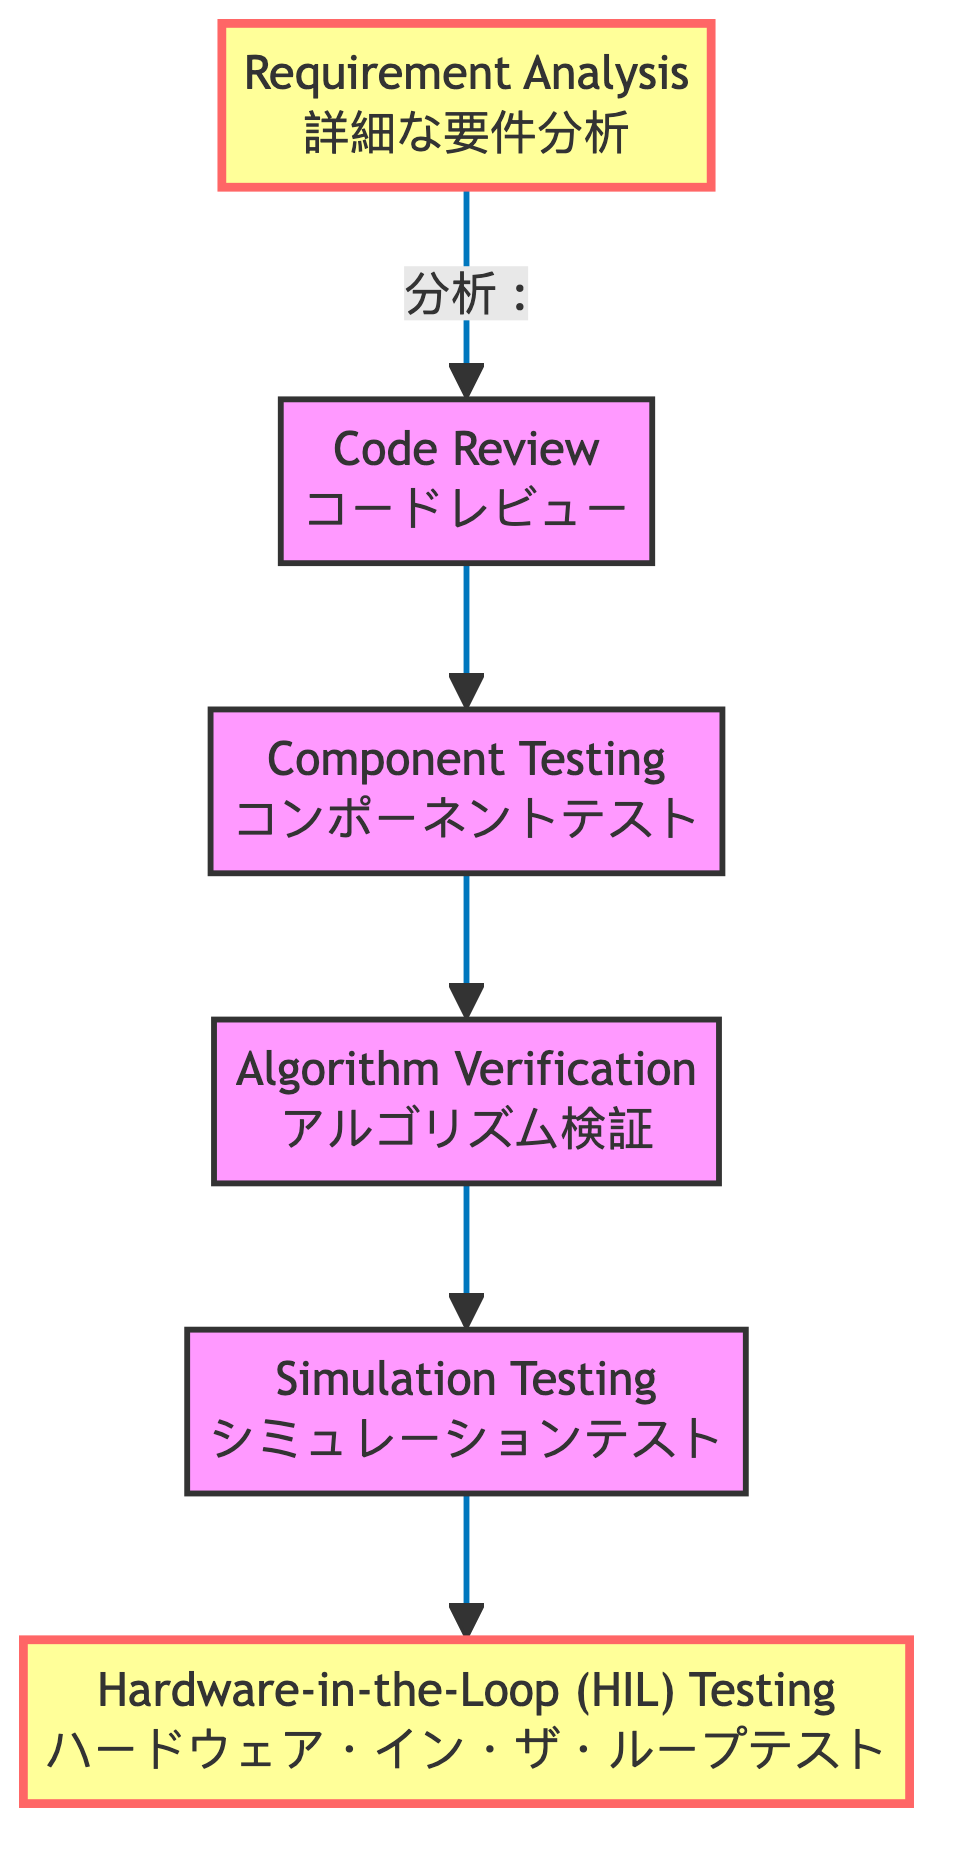What is the top node in the diagram? The diagram's top node is the last step in the sequence that represents the final testing stage. Tracing from the bottom to the top, the flow ends at "Hardware-in-the-Loop (HIL) Testing," which is the last node in the flowchart.
Answer: Hardware-in-the-Loop (HIL) Testing How many nodes are present in the diagram? Counting the nodes in the diagram, we find that there are six distinct steps representing different testing stages. By enumerating each labeled box, we confirm the total node count, which is six.
Answer: 6 Which node follows "Code Review" in the flow? According to the flow direction indicated by the arrows, the node that directly follows "Code Review" is "Component Testing." As the diagram illustrates the progression from one testing step to the next, "Code Review" leads into "Component Testing."
Answer: Component Testing What is the relationship between "Algorithm Verification" and "Simulation Testing"? The relationship can be understood by examining the flow of the diagram. "Algorithm Verification" feeds into "Simulation Testing," indicating that the verification step must happen before running the simulations. This direct connection shows the order of operations.
Answer: Algorithm Verification leads to Simulation Testing What step comes before "Component Testing"? To find the step that precedes "Component Testing," we follow the arrows backward from that node. The diagram indicates that "Code Review" is the step that comes just before it. This sequential view makes it clear how the testing phases build on each other.
Answer: Code Review Why is "Requirement Analysis" highlighted? The diagram highlights "Requirement Analysis" to indicate that it is a foundational step, serving as the starting point for all subsequent testing activities. This highlighting draws attention to its importance in initiating the testing workflow for robot locomotion algorithms.
Answer: It is the starting point What is the significance of the arrows pointing up in the diagram? The arrows pointing upwards symbolize the flow of process stages, indicating a progression from initial analysis to the final testing phase. This upward direction conveys the idea that each stage builds upon the previous one, culminating in comprehensive testing.
Answer: Progression of stages How many dependencies does "Requirement Analysis" have? By analyzing the "Requirement Analysis" node in the diagram, we see it has no dependencies listed; this means it does not require any prior steps to commence. Therefore, it serves as the initial step in the overall testing process.
Answer: 0 Which node is the last phase of testing? The last phase, as indicated by the upward flow, is "Hardware-in-the-Loop (HIL) Testing." By identifying the endpoint of the diagram’s progression, we conclude that this final testing stage integrates real-time performance evaluation of the locomotion algorithms.
Answer: Hardware-in-the-Loop (HIL) Testing 